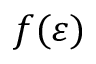Convert formula to latex. <formula><loc_0><loc_0><loc_500><loc_500>f ( \varepsilon )</formula> 